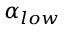Convert formula to latex. <formula><loc_0><loc_0><loc_500><loc_500>\alpha _ { l o w }</formula> 